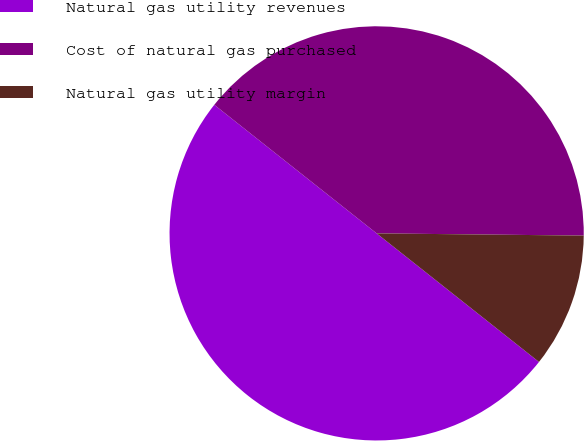<chart> <loc_0><loc_0><loc_500><loc_500><pie_chart><fcel>Natural gas utility revenues<fcel>Cost of natural gas purchased<fcel>Natural gas utility margin<nl><fcel>50.0%<fcel>39.51%<fcel>10.49%<nl></chart> 